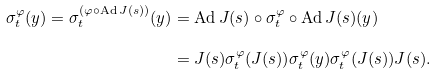<formula> <loc_0><loc_0><loc_500><loc_500>\sigma ^ { \varphi } _ { t } ( y ) = \sigma ^ { ( \varphi \circ \text {Ad} \, J ( s ) ) } _ { t } ( y ) & = \text {Ad} \, J ( s ) \circ \sigma ^ { \varphi } _ { t } \circ \text {Ad} \, J ( s ) ( y ) \\ & = J ( s ) \sigma ^ { \varphi } _ { t } ( J ( s ) ) \sigma ^ { \varphi } _ { t } ( y ) \sigma ^ { \varphi } _ { t } ( J ( s ) ) J ( s ) .</formula> 